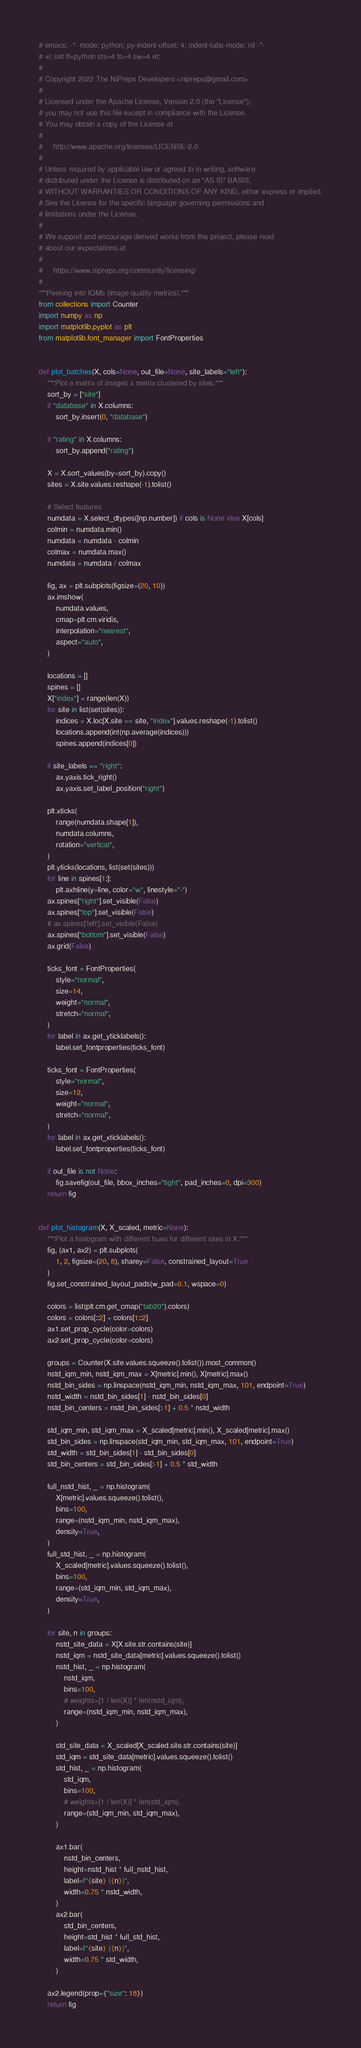<code> <loc_0><loc_0><loc_500><loc_500><_Python_># emacs: -*- mode: python; py-indent-offset: 4; indent-tabs-mode: nil -*-
# vi: set ft=python sts=4 ts=4 sw=4 et:
#
# Copyright 2022 The NiPreps Developers <nipreps@gmail.com>
#
# Licensed under the Apache License, Version 2.0 (the "License");
# you may not use this file except in compliance with the License.
# You may obtain a copy of the License at
#
#     http://www.apache.org/licenses/LICENSE-2.0
#
# Unless required by applicable law or agreed to in writing, software
# distributed under the License is distributed on an "AS IS" BASIS,
# WITHOUT WARRANTIES OR CONDITIONS OF ANY KIND, either express or implied.
# See the License for the specific language governing permissions and
# limitations under the License.
#
# We support and encourage derived works from this project, please read
# about our expectations at
#
#     https://www.nipreps.org/community/licensing/
#
"""Peeking into IQMs (image quality metrics)."""
from collections import Counter
import numpy as np
import matplotlib.pyplot as plt
from matplotlib.font_manager import FontProperties


def plot_batches(X, cols=None, out_file=None, site_labels="left"):
    """Plot a matrix of images x metrix clustered by sites."""
    sort_by = ["site"]
    if "database" in X.columns:
        sort_by.insert(0, "database")

    if "rating" in X.columns:
        sort_by.append("rating")

    X = X.sort_values(by=sort_by).copy()
    sites = X.site.values.reshape(-1).tolist()

    # Select features
    numdata = X.select_dtypes([np.number]) if cols is None else X[cols]
    colmin = numdata.min()
    numdata = numdata - colmin
    colmax = numdata.max()
    numdata = numdata / colmax

    fig, ax = plt.subplots(figsize=(20, 10))
    ax.imshow(
        numdata.values,
        cmap=plt.cm.viridis,
        interpolation="nearest",
        aspect="auto",
    )

    locations = []
    spines = []
    X["index"] = range(len(X))
    for site in list(set(sites)):
        indices = X.loc[X.site == site, "index"].values.reshape(-1).tolist()
        locations.append(int(np.average(indices)))
        spines.append(indices[0])

    if site_labels == "right":
        ax.yaxis.tick_right()
        ax.yaxis.set_label_position("right")

    plt.xticks(
        range(numdata.shape[1]),
        numdata.columns,
        rotation="vertical",
    )
    plt.yticks(locations, list(set(sites)))
    for line in spines[1:]:
        plt.axhline(y=line, color="w", linestyle="-")
    ax.spines["right"].set_visible(False)
    ax.spines["top"].set_visible(False)
    # ax.spines['left'].set_visible(False)
    ax.spines["bottom"].set_visible(False)
    ax.grid(False)

    ticks_font = FontProperties(
        style="normal",
        size=14,
        weight="normal",
        stretch="normal",
    )
    for label in ax.get_yticklabels():
        label.set_fontproperties(ticks_font)

    ticks_font = FontProperties(
        style="normal",
        size=12,
        weight="normal",
        stretch="normal",
    )
    for label in ax.get_xticklabels():
        label.set_fontproperties(ticks_font)

    if out_file is not None:
        fig.savefig(out_file, bbox_inches="tight", pad_inches=0, dpi=300)
    return fig


def plot_histogram(X, X_scaled, metric=None):
    """Plot a histogram with different hues for different sites in X."""
    fig, (ax1, ax2) = plt.subplots(
        1, 2, figsize=(20, 8), sharey=False, constrained_layout=True
    )
    fig.set_constrained_layout_pads(w_pad=0.1, wspace=0)

    colors = list(plt.cm.get_cmap("tab20").colors)
    colors = colors[::2] + colors[1::2]
    ax1.set_prop_cycle(color=colors)
    ax2.set_prop_cycle(color=colors)

    groups = Counter(X.site.values.squeeze().tolist()).most_common()
    nstd_iqm_min, nstd_iqm_max = X[metric].min(), X[metric].max()
    nstd_bin_sides = np.linspace(nstd_iqm_min, nstd_iqm_max, 101, endpoint=True)
    nstd_width = nstd_bin_sides[1] - nstd_bin_sides[0]
    nstd_bin_centers = nstd_bin_sides[:-1] + 0.5 * nstd_width

    std_iqm_min, std_iqm_max = X_scaled[metric].min(), X_scaled[metric].max()
    std_bin_sides = np.linspace(std_iqm_min, std_iqm_max, 101, endpoint=True)
    std_width = std_bin_sides[1] - std_bin_sides[0]
    std_bin_centers = std_bin_sides[:-1] + 0.5 * std_width

    full_nstd_hist, _ = np.histogram(
        X[metric].values.squeeze().tolist(),
        bins=100,
        range=(nstd_iqm_min, nstd_iqm_max),
        density=True,
    )
    full_std_hist, _ = np.histogram(
        X_scaled[metric].values.squeeze().tolist(),
        bins=100,
        range=(std_iqm_min, std_iqm_max),
        density=True,
    )

    for site, n in groups:
        nstd_site_data = X[X.site.str.contains(site)]
        nstd_iqm = nstd_site_data[metric].values.squeeze().tolist()
        nstd_hist, _ = np.histogram(
            nstd_iqm,
            bins=100,
            # weights=[1 / len(X)] * len(nstd_iqm),
            range=(nstd_iqm_min, nstd_iqm_max),
        )

        std_site_data = X_scaled[X_scaled.site.str.contains(site)]
        std_iqm = std_site_data[metric].values.squeeze().tolist()
        std_hist, _ = np.histogram(
            std_iqm,
            bins=100,
            # weights=[1 / len(X)] * len(std_iqm),
            range=(std_iqm_min, std_iqm_max),
        )

        ax1.bar(
            nstd_bin_centers,
            height=nstd_hist * full_nstd_hist,
            label=f"{site} ({n})",
            width=0.75 * nstd_width,
        )
        ax2.bar(
            std_bin_centers,
            height=std_hist * full_std_hist,
            label=f"{site} ({n})",
            width=0.75 * std_width,
        )

    ax2.legend(prop={"size": 18})
    return fig
</code> 